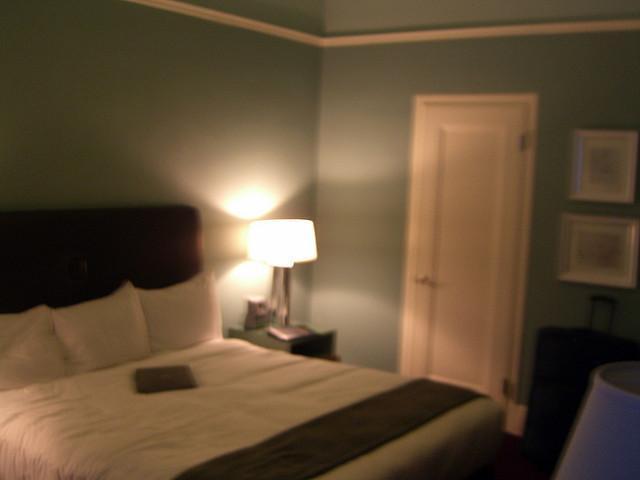How many pillows are there?
Give a very brief answer. 3. How many pillows are on the bed?
Give a very brief answer. 3. How many beds are in this room?
Give a very brief answer. 1. How many panels are in the door?
Give a very brief answer. 1. How many lights are on?
Give a very brief answer. 1. How many pictures are on the wall?
Give a very brief answer. 2. How many lamps are on?
Give a very brief answer. 1. How many lamps are in the picture?
Give a very brief answer. 1. 